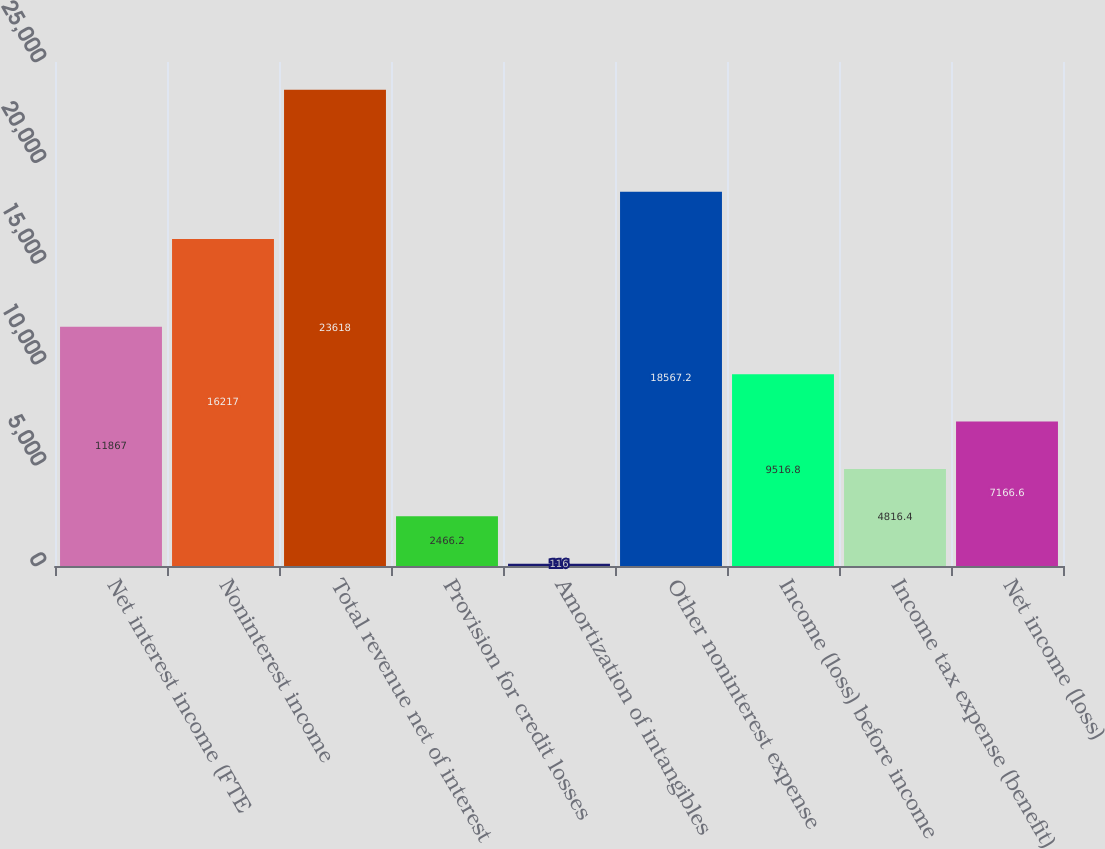Convert chart to OTSL. <chart><loc_0><loc_0><loc_500><loc_500><bar_chart><fcel>Net interest income (FTE<fcel>Noninterest income<fcel>Total revenue net of interest<fcel>Provision for credit losses<fcel>Amortization of intangibles<fcel>Other noninterest expense<fcel>Income (loss) before income<fcel>Income tax expense (benefit)<fcel>Net income (loss)<nl><fcel>11867<fcel>16217<fcel>23618<fcel>2466.2<fcel>116<fcel>18567.2<fcel>9516.8<fcel>4816.4<fcel>7166.6<nl></chart> 